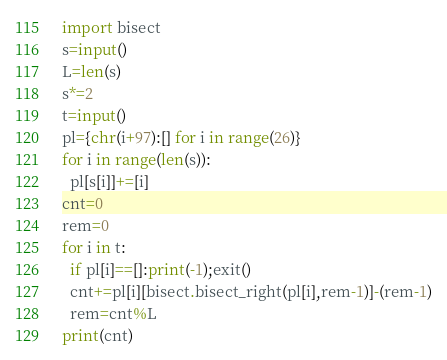Convert code to text. <code><loc_0><loc_0><loc_500><loc_500><_Python_>import bisect
s=input()
L=len(s)
s*=2
t=input()
pl={chr(i+97):[] for i in range(26)}
for i in range(len(s)):
  pl[s[i]]+=[i]
cnt=0
rem=0
for i in t:
  if pl[i]==[]:print(-1);exit()
  cnt+=pl[i][bisect.bisect_right(pl[i],rem-1)]-(rem-1)
  rem=cnt%L
print(cnt)</code> 